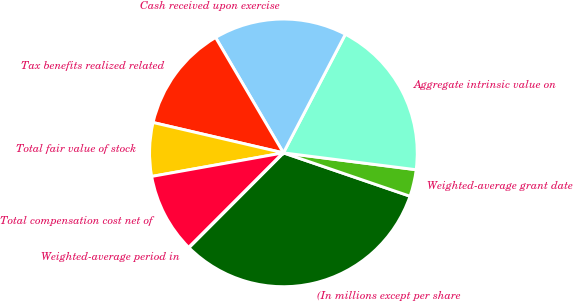Convert chart. <chart><loc_0><loc_0><loc_500><loc_500><pie_chart><fcel>(In millions except per share<fcel>Weighted-average grant date<fcel>Aggregate intrinsic value on<fcel>Cash received upon exercise<fcel>Tax benefits realized related<fcel>Total fair value of stock<fcel>Total compensation cost net of<fcel>Weighted-average period in<nl><fcel>32.23%<fcel>3.24%<fcel>19.35%<fcel>16.12%<fcel>12.9%<fcel>6.46%<fcel>9.68%<fcel>0.02%<nl></chart> 